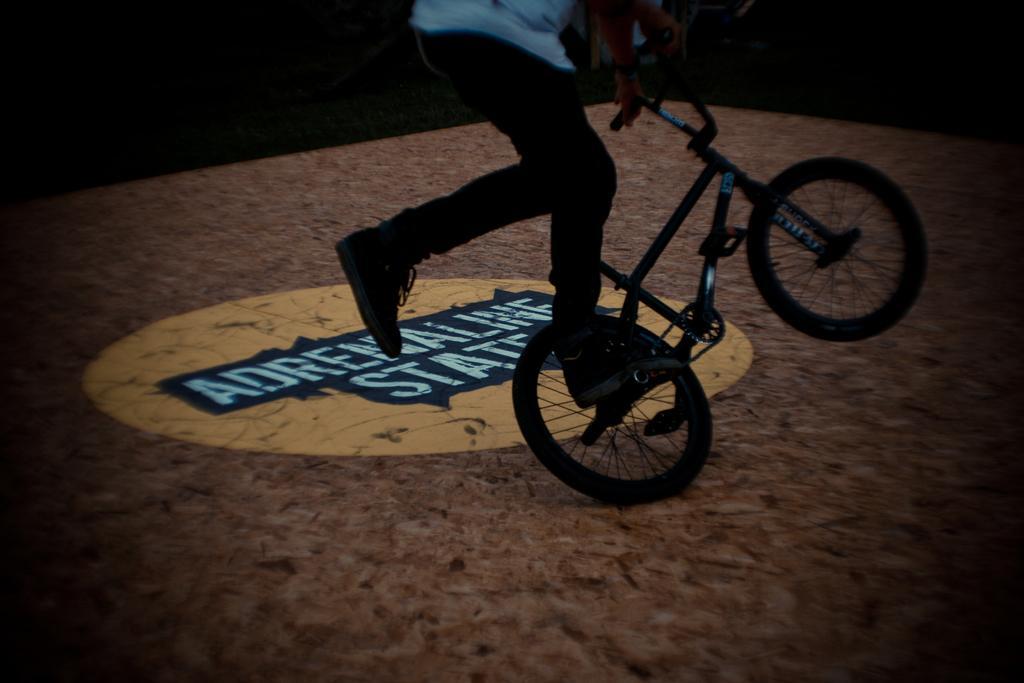Can you describe this image briefly? The person in the image is doing stunt on the bicycle in the stadium. 